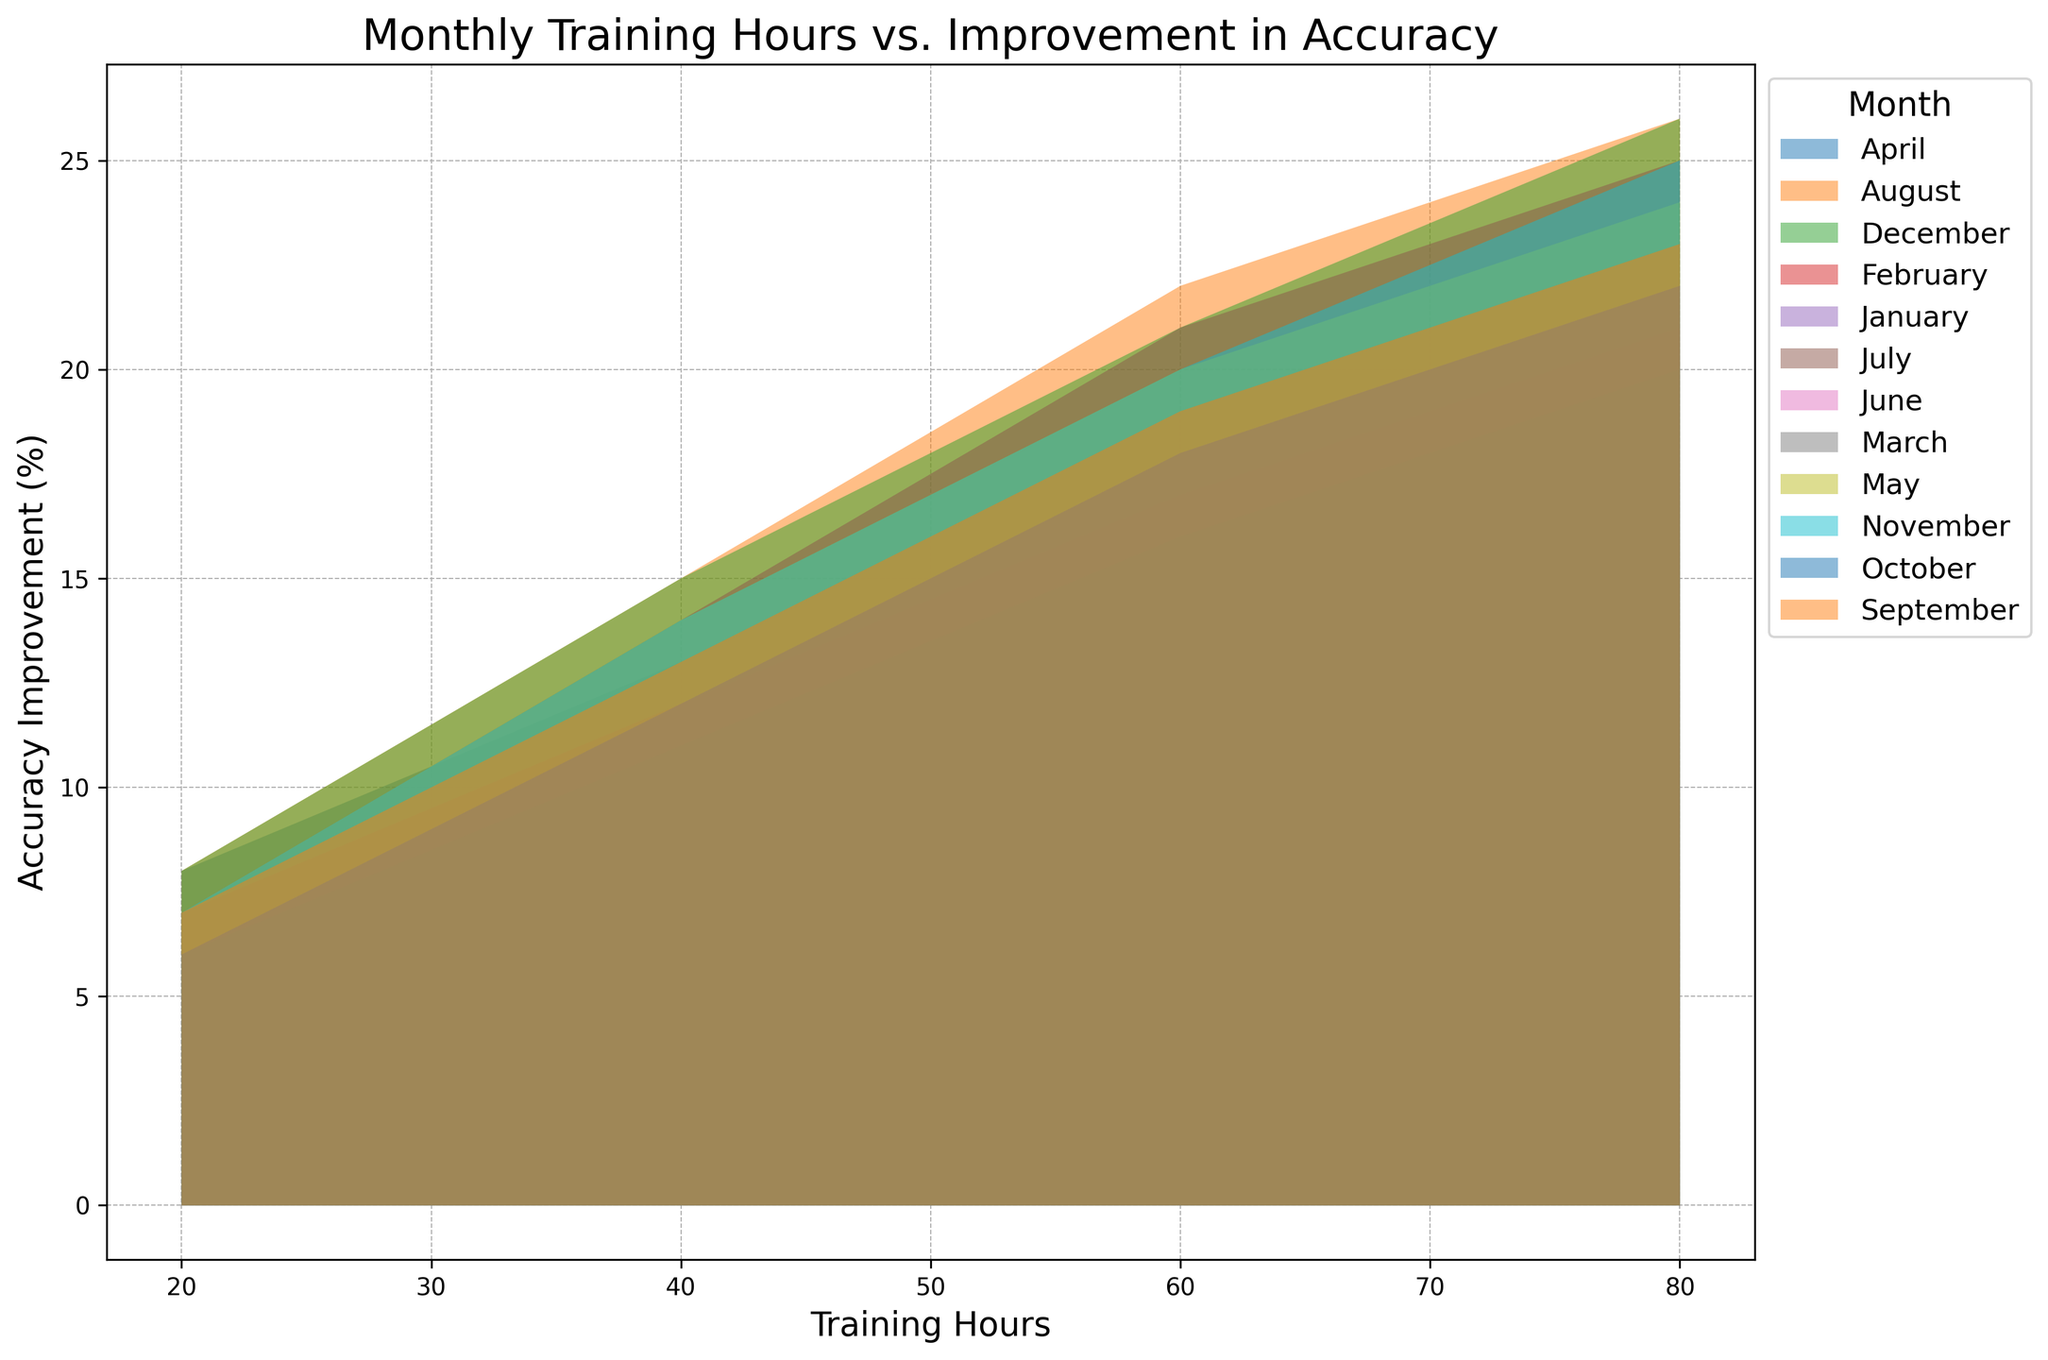What trend can be seen in the relationship between training hours and accuracy improvement across all months? Each month exhibits a general trend where increased training hours correspond to higher accuracy improvement. The relationship appears roughly linear, with more training leading to incremental gains.
Answer: More hours, more improvement During which month did players achieve the highest accuracy improvement for 80 training hours? Find the highest point on the 80 training hours axis for each month. December and August both reach 26%, which is the highest improvement among all months.
Answer: December and August How does the accuracy improvement in March compare to April for 60 training hours? Look at the value for 60 training hours in March and compare it with the value in April. March shows 16% while April has a higher improvement of 19%.
Answer: April is higher If a player wishes to see a steady improvement from 20 to 80 hours of training within a single month, which month's data reflects the smoothest gradient of improvement? Examine the slopes of the areas for each month between 20 and 80 hours. April shows a consistent and smooth increase in accuracy improvement from 8% to 23%, indicating a steady gradient.
Answer: April What is the difference in accuracy improvement between January and July at 40 training hours? Subtract the accuracy improvement in January at 40 training hours (10%) from that in July at 40 training hours (14%). The difference is 4%.
Answer: 4% Which month shows the least improvement in accuracy for 20 training hours? Identify the lowest value on the 20 training hours axis across all months. Both January and March have the lowest improvement at 5% and 6%, respectively, with January being the least at 5%.
Answer: January Is there any month where the accuracy improvement for 40 training hours matches the improvement for 60 training hours in a different month? Compare the values across the months. In January, the improvement for 40 hours is 10%, which matches the improvement of May (20%) for 20 hours. However, no 40-hour improvement matches exactly with any 60-hour improvement.
Answer: No match How does the spread of accuracy improvements differ between January and June for 20 to 80 training hours? Look at the range of accuracy improvements from 20 to 80 training hours for both months. January ranges from 5% to 18% (13% spread) while June ranges from 6% to 22% (16% spread). June shows a larger spread compared to January.
Answer: June has a larger spread What is the average improvement in accuracy for August if the training is 40, 60, and 80 hours? Calculate the average of the accuracy improvements for August at 40, 60, and 80 hours. That gives us (15% + 22% + 26%) / 3, which equals 21%.
Answer: 21% 